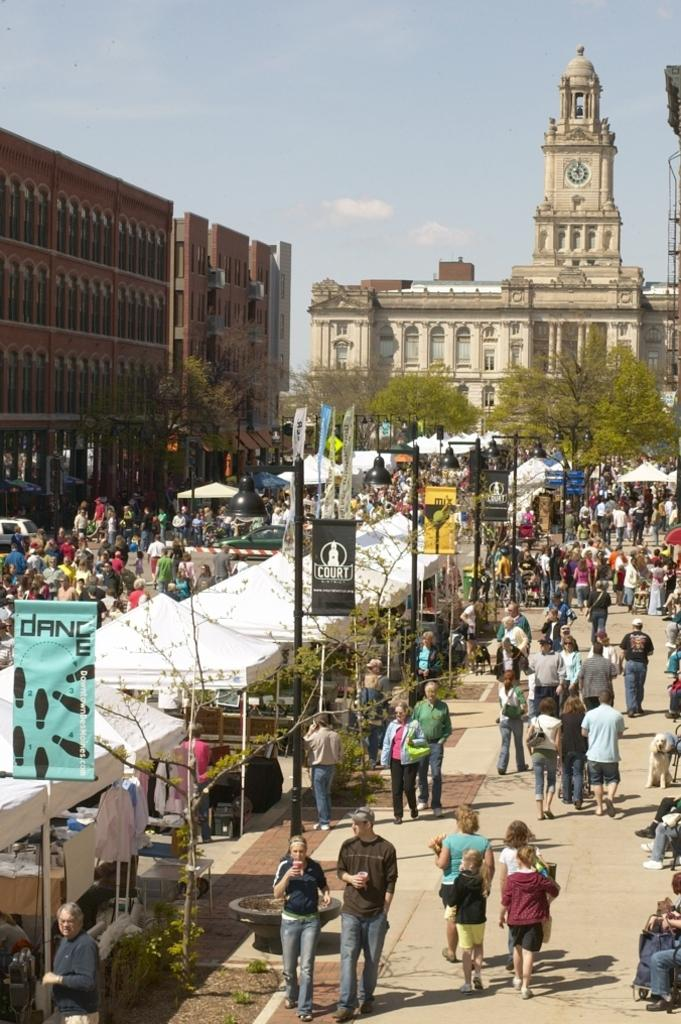How many people are in the image? There is a group of people in the image, but the exact number cannot be determined from the provided facts. What can be seen hanging in the image? There are banners in the image. What type of structures are present to provide light? There are lights on poles in the image. What type of temporary shelter is present in the image? There are tents in the image. What type of vehicle is visible in the image? There is a vehicle in the image. What type of natural vegetation is present in the image? There are trees in the image. What can be seen in the background of the image? There are buildings and the sky visible in the background of the image. What type of goat is being used to slow down the vehicle in the image? There is no goat present in the image, and therefore no such activity can be observed. What type of sweater is being worn by the people in the image? The provided facts do not mention any clothing worn by the people in the image, so it cannot be determined from the image. 